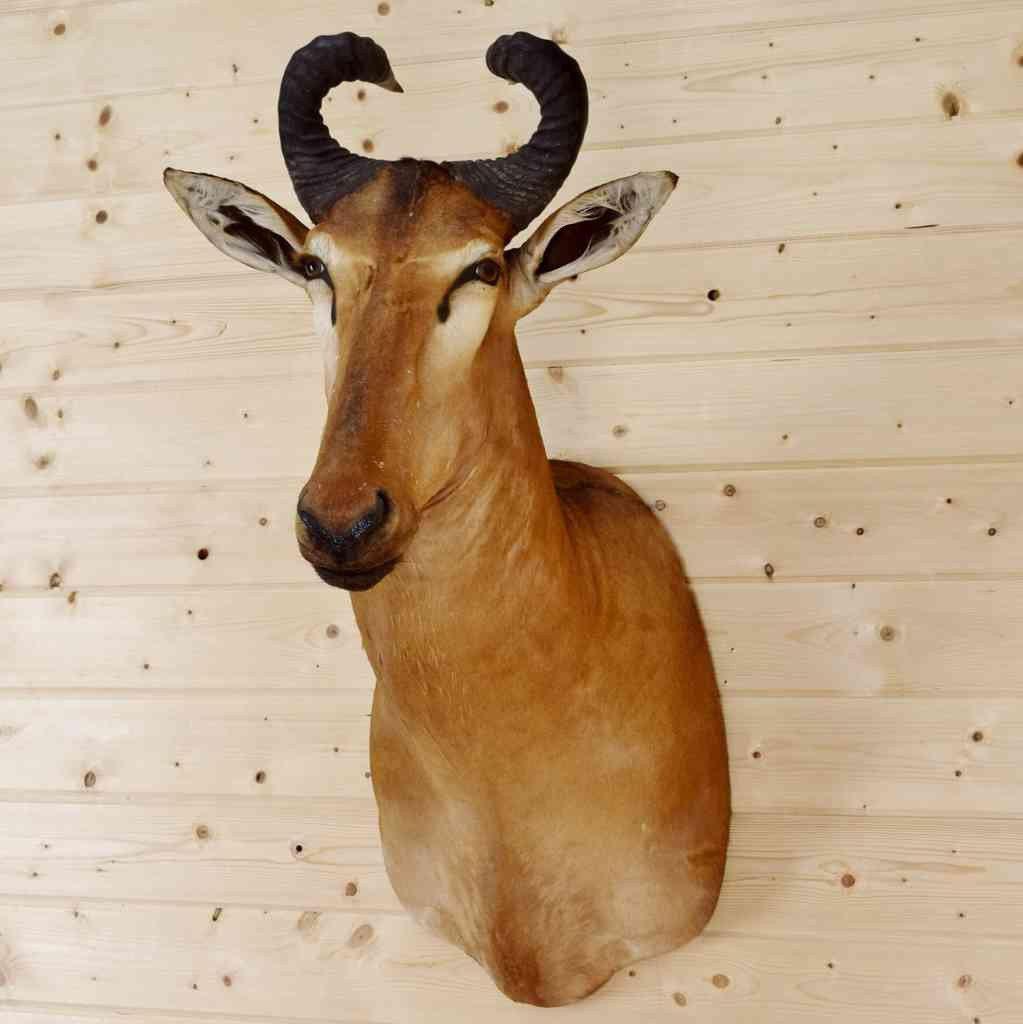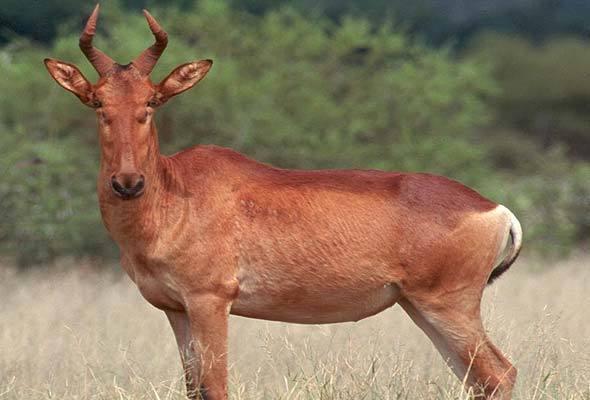The first image is the image on the left, the second image is the image on the right. Analyze the images presented: Is the assertion "There are two antelope heads shown without a body." valid? Answer yes or no. No. The first image is the image on the left, the second image is the image on the right. Considering the images on both sides, is "An image shows the head of a horned animal mounted on a knotty wood plank wall." valid? Answer yes or no. Yes. 